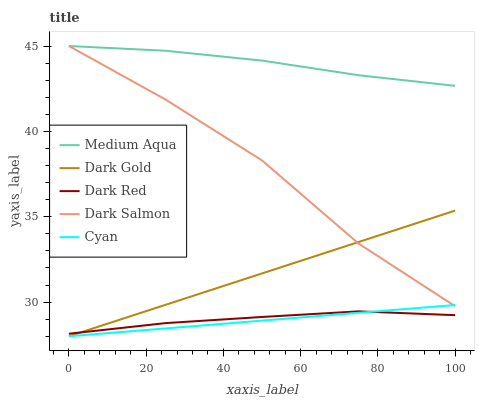Does Medium Aqua have the minimum area under the curve?
Answer yes or no. No. Does Cyan have the maximum area under the curve?
Answer yes or no. No. Is Cyan the smoothest?
Answer yes or no. No. Is Cyan the roughest?
Answer yes or no. No. Does Medium Aqua have the lowest value?
Answer yes or no. No. Does Cyan have the highest value?
Answer yes or no. No. Is Dark Gold less than Medium Aqua?
Answer yes or no. Yes. Is Medium Aqua greater than Dark Red?
Answer yes or no. Yes. Does Dark Gold intersect Medium Aqua?
Answer yes or no. No. 